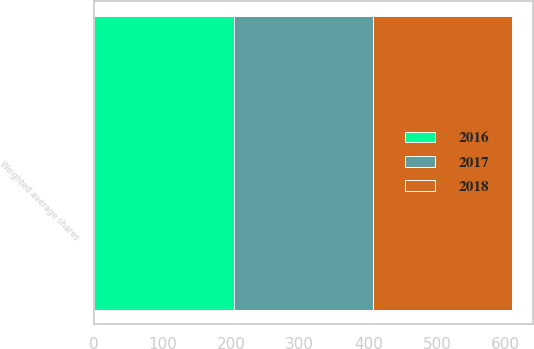<chart> <loc_0><loc_0><loc_500><loc_500><stacked_bar_chart><ecel><fcel>Weighted average shares<nl><fcel>2017<fcel>203.5<nl><fcel>2016<fcel>203.7<nl><fcel>2018<fcel>202.4<nl></chart> 